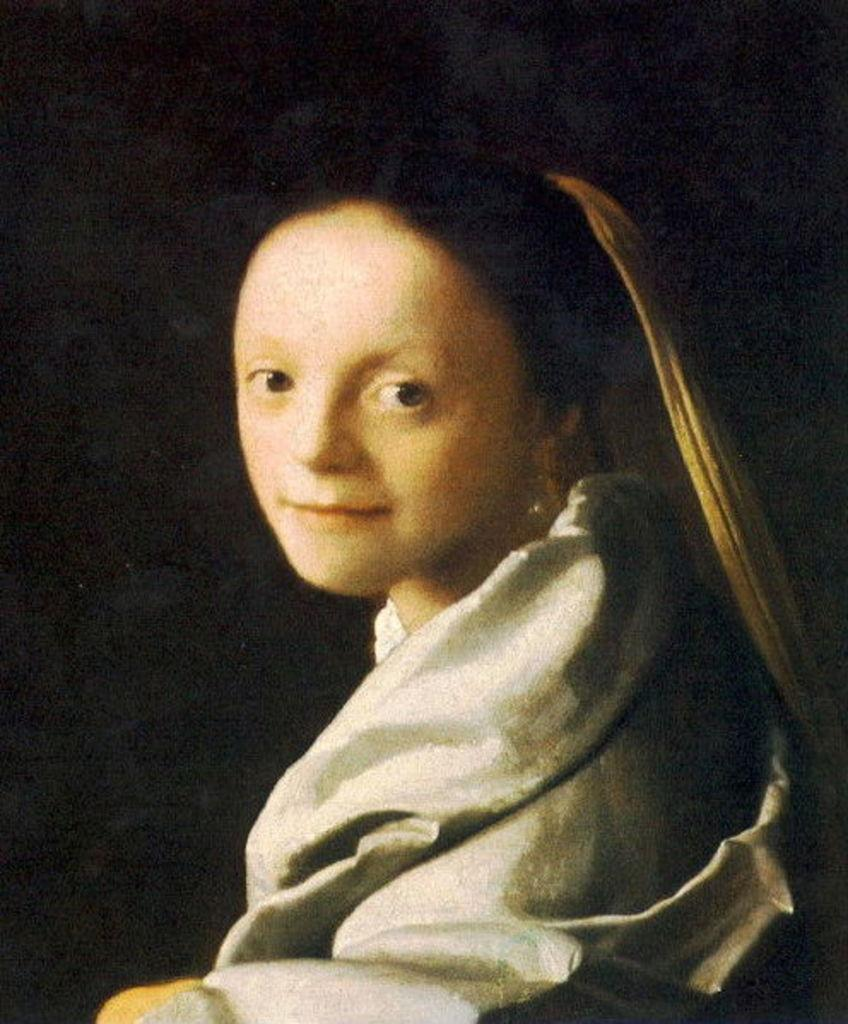What is the main subject of the image? There is a painting in the image. What is depicted in the painting? The painting depicts a woman. What is the woman wearing in the painting? The woman is wearing a white dress in the painting. How would you describe the background of the painting? The background of the painting appears to be dark. How many clams are present in the painting? There are no clams present in the painting; it depicts a woman wearing a white dress against a dark background. 